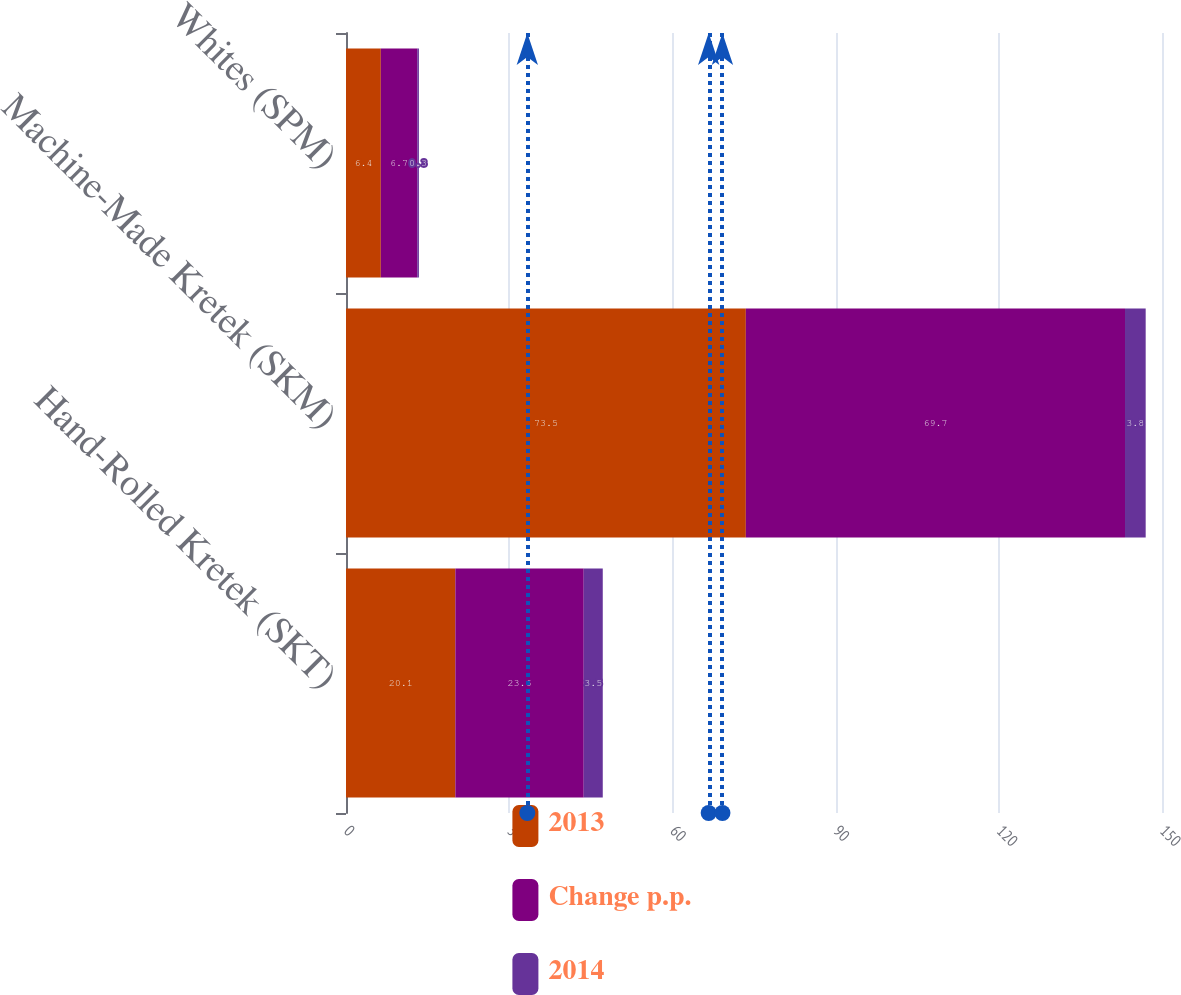Convert chart to OTSL. <chart><loc_0><loc_0><loc_500><loc_500><stacked_bar_chart><ecel><fcel>Hand-Rolled Kretek (SKT)<fcel>Machine-Made Kretek (SKM)<fcel>Whites (SPM)<nl><fcel>2013<fcel>20.1<fcel>73.5<fcel>6.4<nl><fcel>Change p.p.<fcel>23.6<fcel>69.7<fcel>6.7<nl><fcel>2014<fcel>3.5<fcel>3.8<fcel>0.3<nl></chart> 